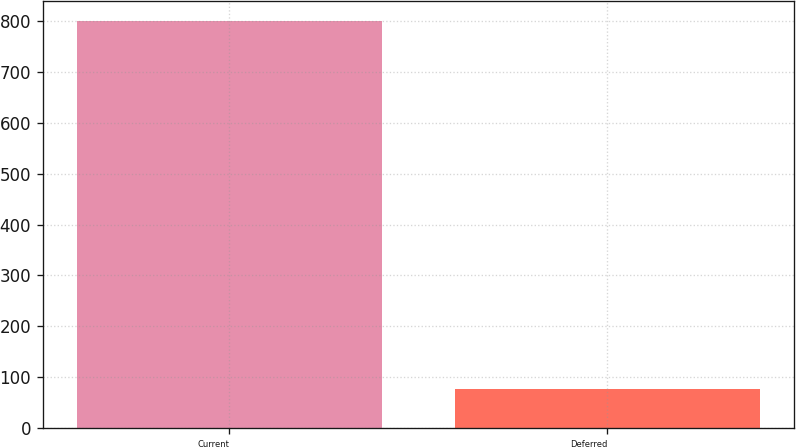Convert chart to OTSL. <chart><loc_0><loc_0><loc_500><loc_500><bar_chart><fcel>Current<fcel>Deferred<nl><fcel>799<fcel>76<nl></chart> 